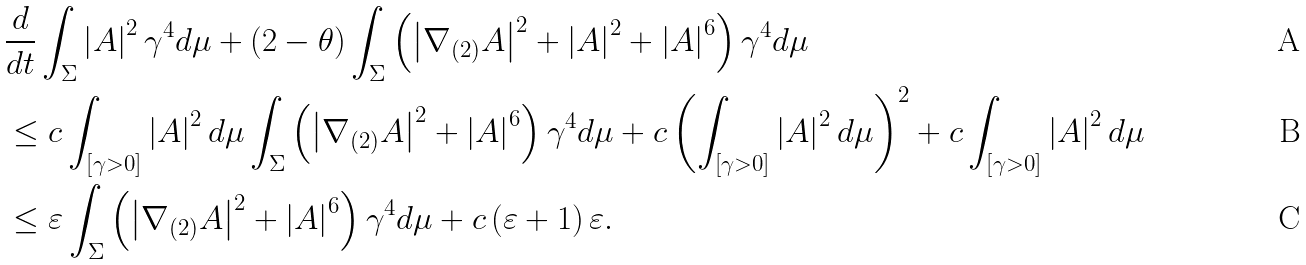<formula> <loc_0><loc_0><loc_500><loc_500>& \frac { d } { d t } \int _ { \Sigma } \left | A \right | ^ { 2 } \gamma ^ { 4 } d \mu + \left ( 2 - \theta \right ) \int _ { \Sigma } \left ( \left | \nabla _ { ( 2 ) } A \right | ^ { 2 } + \left | A \right | ^ { 2 } + \left | A \right | ^ { 6 } \right ) \gamma ^ { 4 } d \mu \\ & \leq c \int _ { \left [ \gamma > 0 \right ] } \left | A \right | ^ { 2 } d \mu \int _ { \Sigma } \left ( \left | \nabla _ { ( 2 ) } A \right | ^ { 2 } + \left | A \right | ^ { 6 } \right ) \gamma ^ { 4 } d \mu + c \left ( \int _ { \left [ \gamma > 0 \right ] } \left | A \right | ^ { 2 } d \mu \right ) ^ { 2 } + c \int _ { \left [ \gamma > 0 \right ] } \left | A \right | ^ { 2 } d \mu \\ & \leq \varepsilon \int _ { \Sigma } \left ( \left | \nabla _ { ( 2 ) } A \right | ^ { 2 } + \left | A \right | ^ { 6 } \right ) \gamma ^ { 4 } d \mu + c \left ( \varepsilon + 1 \right ) \varepsilon .</formula> 